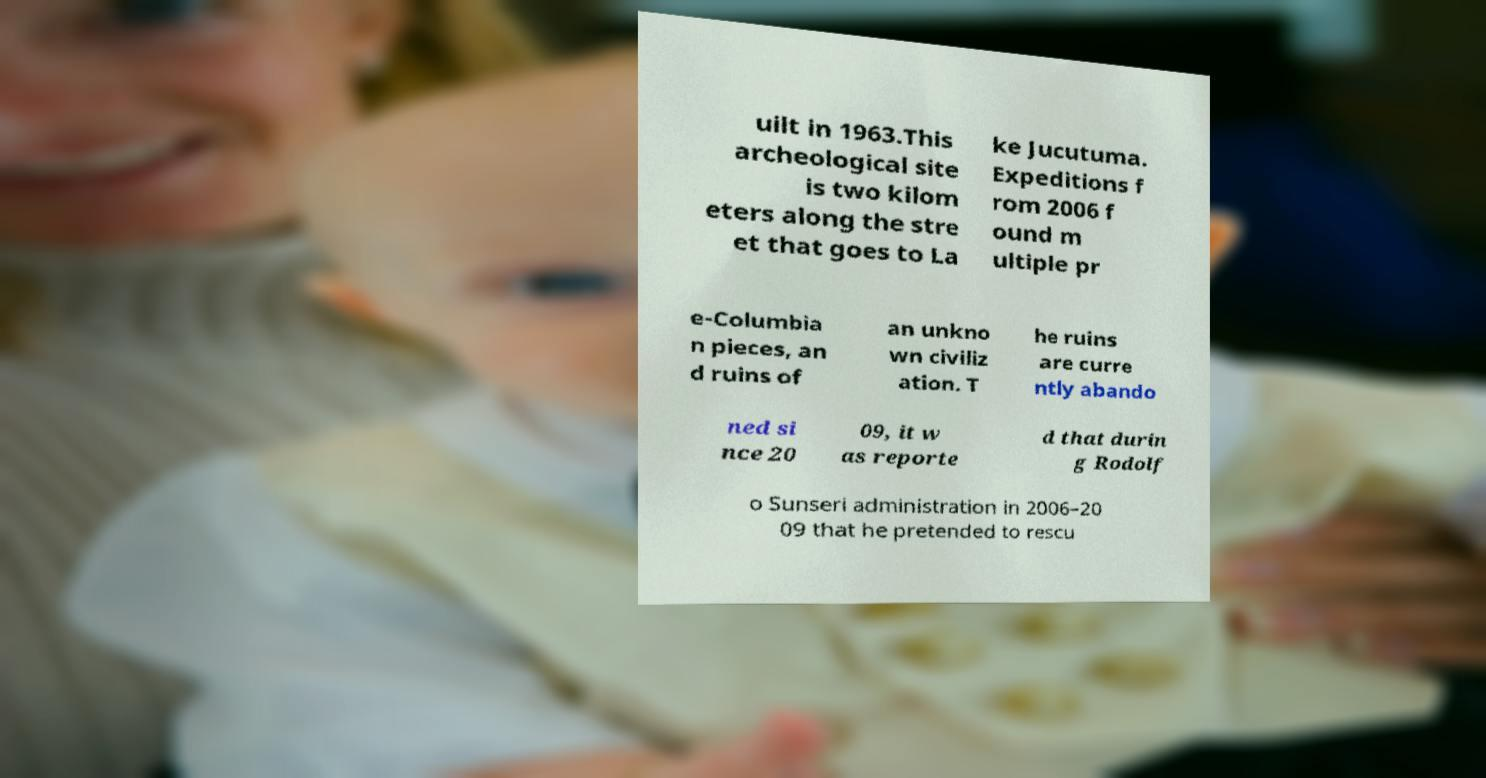Could you extract and type out the text from this image? uilt in 1963.This archeological site is two kilom eters along the stre et that goes to La ke Jucutuma. Expeditions f rom 2006 f ound m ultiple pr e-Columbia n pieces, an d ruins of an unkno wn civiliz ation. T he ruins are curre ntly abando ned si nce 20 09, it w as reporte d that durin g Rodolf o Sunseri administration in 2006–20 09 that he pretended to rescu 